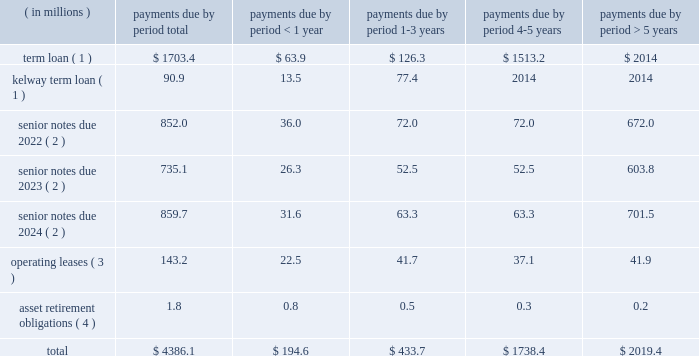Table of contents ended december 31 , 2015 and 2014 , respectively .
The increase in cash provided by accounts payable-inventory financing was primarily due to a new vendor added to our previously existing inventory financing agreement .
For a description of the inventory financing transactions impacting each period , see note 6 ( inventory financing agreements ) to the accompanying consolidated financial statements .
For a description of the debt transactions impacting each period , see note 8 ( long-term debt ) to the accompanying consolidated financial statements .
Net cash used in financing activities decreased $ 56.3 million in 2014 compared to 2013 .
The decrease was primarily driven by several debt refinancing transactions during each period and our july 2013 ipo , which generated net proceeds of $ 424.7 million after deducting underwriting discounts , expenses and transaction costs .
The net impact of our debt transactions resulted in cash outflows of $ 145.9 million and $ 518.3 million during 2014 and 2013 , respectively , as cash was used in each period to reduce our total long-term debt .
For a description of the debt transactions impacting each period , see note 8 ( long-term debt ) to the accompanying consolidated financial statements .
Long-term debt and financing arrangements as of december 31 , 2015 , we had total indebtedness of $ 3.3 billion , of which $ 1.6 billion was secured indebtedness .
At december 31 , 2015 , we were in compliance with the covenants under our various credit agreements and indentures .
The amount of cdw 2019s restricted payment capacity under the senior secured term loan facility was $ 679.7 million at december 31 , 2015 .
For further details regarding our debt and each of the transactions described below , see note 8 ( long-term debt ) to the accompanying consolidated financial statements .
During the year ended december 31 , 2015 , the following events occurred with respect to our debt structure : 2022 on august 1 , 2015 , we consolidated kelway 2019s term loan and kelway 2019s revolving credit facility .
Kelway 2019s term loan is denominated in british pounds .
The kelway revolving credit facility is a multi-currency revolving credit facility under which kelway is permitted to borrow an aggregate amount of a350.0 million ( $ 73.7 million ) as of december 31 , 2015 .
2022 on march 3 , 2015 , we completed the issuance of $ 525.0 million principal amount of 5.0% ( 5.0 % ) senior notes due 2023 which will mature on september 1 , 2023 .
2022 on march 3 , 2015 , we redeemed the remaining $ 503.9 million aggregate principal amount of the 8.5% ( 8.5 % ) senior notes due 2019 , plus accrued and unpaid interest through the date of redemption , april 2 , 2015 .
Inventory financing agreements we have entered into agreements with certain financial intermediaries to facilitate the purchase of inventory from various suppliers under certain terms and conditions .
These amounts are classified separately as accounts payable-inventory financing on the consolidated balance sheets .
We do not incur any interest expense associated with these agreements as balances are paid when they are due .
For further details , see note 6 ( inventory financing agreements ) to the accompanying consolidated financial statements .
Contractual obligations we have future obligations under various contracts relating to debt and interest payments , operating leases and asset retirement obligations .
Our estimated future payments , based on undiscounted amounts , under contractual obligations that existed as of december 31 , 2015 , are as follows: .

As of dec 31 , 2015 , what percentage of total indebtedness was nonsecure? 
Computations: ((3.3 - 1.6) / 3.3)
Answer: 0.51515. 